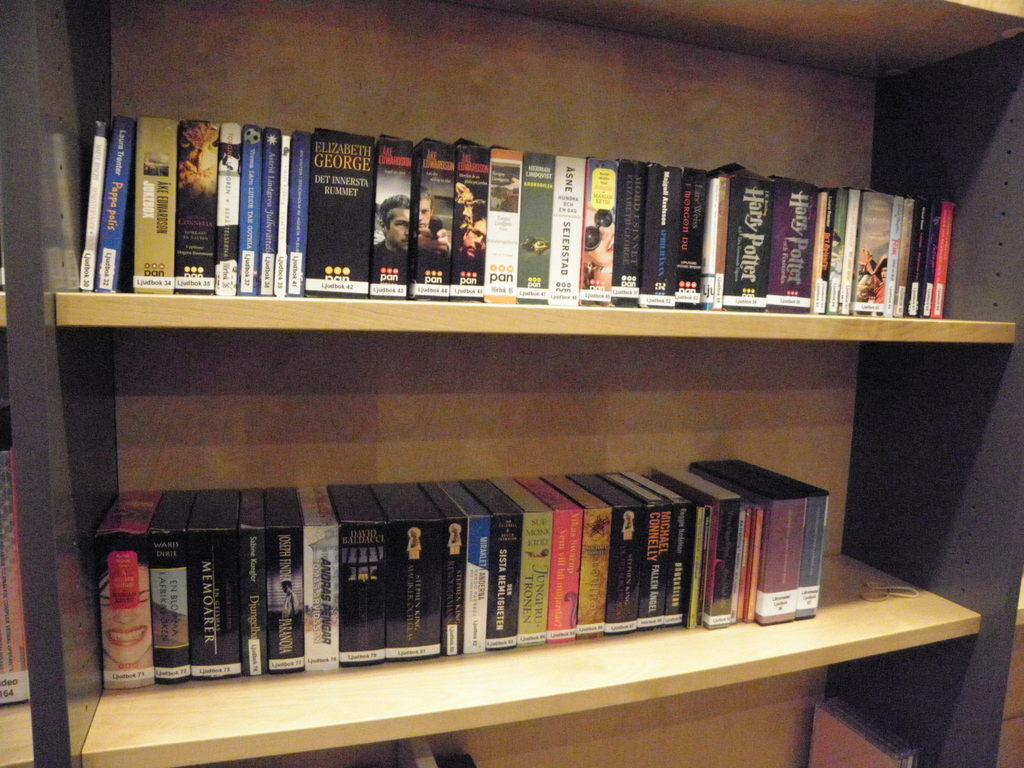What objects are present in the image? There are books in the image. How are the books organized in the image? The books are kept in shelves and arranged in an order. What type of yam is being kicked in the image? There is no yam or act of kicking present in the image; it features books arranged in shelves. 